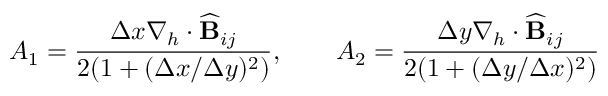Convert formula to latex. <formula><loc_0><loc_0><loc_500><loc_500>A _ { 1 } = \frac { \Delta x \nabla _ { h } \cdot \widehat { B } _ { i j } } { 2 ( 1 + ( \Delta x / \Delta y ) ^ { 2 } ) } , \quad A _ { 2 } = \frac { \Delta y \nabla _ { h } \cdot \widehat { B } _ { i j } } { 2 ( 1 + ( \Delta y / \Delta x ) ^ { 2 } ) }</formula> 